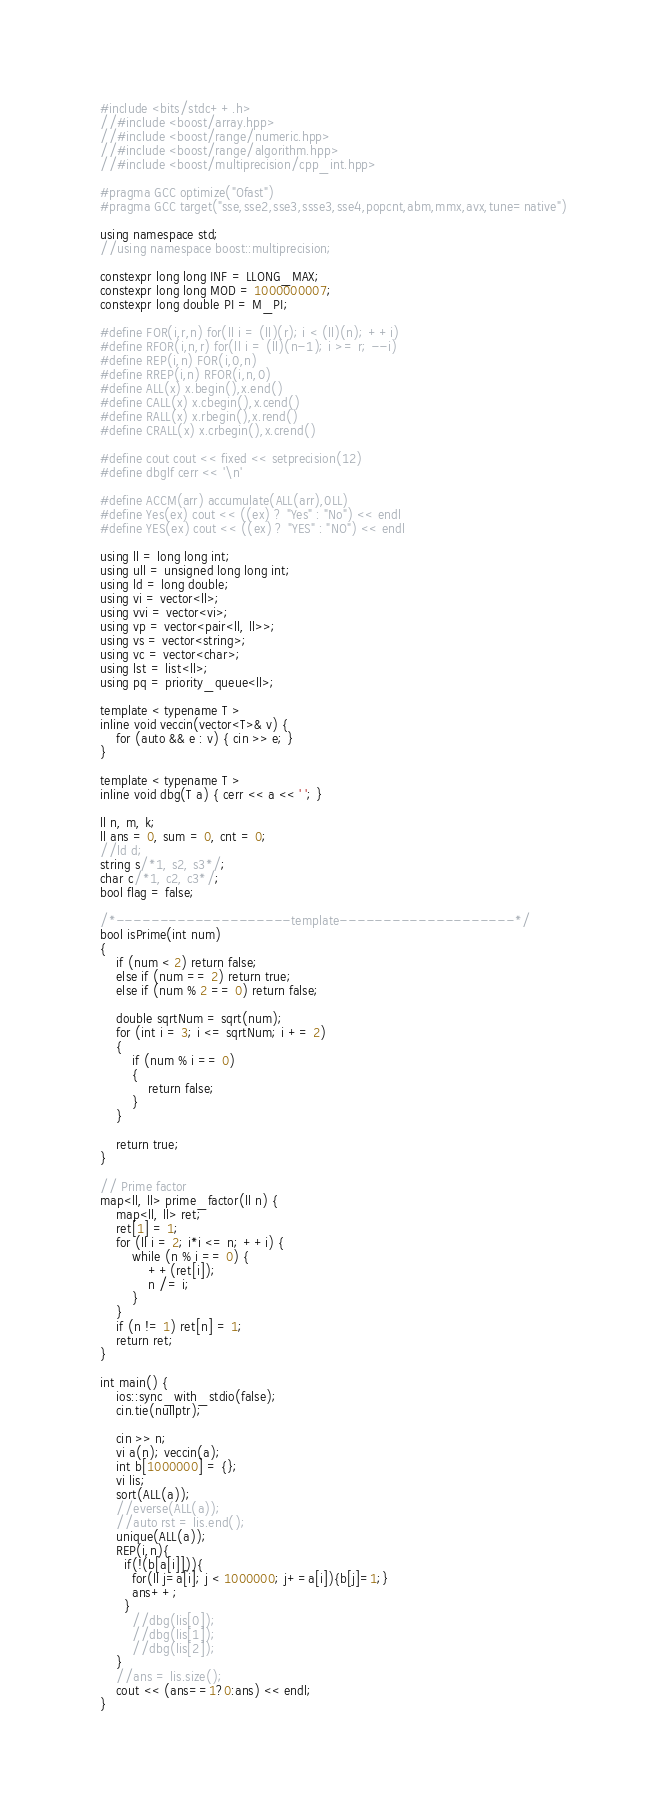Convert code to text. <code><loc_0><loc_0><loc_500><loc_500><_C++_>#include <bits/stdc++.h>
//#include <boost/array.hpp>
//#include <boost/range/numeric.hpp>
//#include <boost/range/algorithm.hpp>
//#include <boost/multiprecision/cpp_int.hpp>

#pragma GCC optimize("Ofast")
#pragma GCC target("sse,sse2,sse3,ssse3,sse4,popcnt,abm,mmx,avx,tune=native")

using namespace std;
//using namespace boost::multiprecision;

constexpr long long INF = LLONG_MAX;
constexpr long long MOD = 1000000007;
constexpr long double PI = M_PI;

#define FOR(i,r,n) for(ll i = (ll)(r); i < (ll)(n); ++i)
#define RFOR(i,n,r) for(ll i = (ll)(n-1); i >= r; --i)
#define REP(i,n) FOR(i,0,n)
#define RREP(i,n) RFOR(i,n,0)
#define ALL(x) x.begin(),x.end()
#define CALL(x) x.cbegin(),x.cend()
#define RALL(x) x.rbegin(),x.rend()
#define CRALL(x) x.crbegin(),x.crend()

#define cout cout << fixed << setprecision(12)
#define dbglf cerr << '\n'

#define ACCM(arr) accumulate(ALL(arr),0LL)
#define Yes(ex) cout << ((ex) ? "Yes" : "No") << endl
#define YES(ex) cout << ((ex) ? "YES" : "NO") << endl

using ll = long long int;
using ull = unsigned long long int;
using ld = long double;
using vi = vector<ll>;
using vvi = vector<vi>;
using vp = vector<pair<ll, ll>>;
using vs = vector<string>;
using vc = vector<char>;
using lst = list<ll>;
using pq = priority_queue<ll>;

template < typename T >
inline void veccin(vector<T>& v) {
    for (auto && e : v) { cin >> e; }
}

template < typename T >
inline void dbg(T a) { cerr << a << ' '; }

ll n, m, k;
ll ans = 0, sum = 0, cnt = 0;
//ld d;
string s/*1, s2, s3*/;
char c/*1, c2, c3*/;
bool flag = false;

/*--------------------template--------------------*/
bool isPrime(int num)
{
    if (num < 2) return false;
    else if (num == 2) return true;
    else if (num % 2 == 0) return false;

    double sqrtNum = sqrt(num);
    for (int i = 3; i <= sqrtNum; i += 2)
    {
        if (num % i == 0)
        {
            return false;
        }
    }

    return true;
}

// Prime factor
map<ll, ll> prime_factor(ll n) {
    map<ll, ll> ret;
    ret[1] = 1;
    for (ll i = 2; i*i <= n; ++i) {
        while (n % i == 0) {
            ++(ret[i]);
            n /= i;
        }
    }
    if (n != 1) ret[n] = 1;
    return ret;
}

int main() {
    ios::sync_with_stdio(false);
    cin.tie(nullptr);

    cin >> n;
    vi a(n); veccin(a);
	int b[1000000] = {};
  	vi lis;
	sort(ALL(a));
	//everse(ALL(a));
  	//auto rst = lis.end();
	unique(ALL(a));
    REP(i,n){
      if(!(b[a[i]])){
      	for(ll j=a[i]; j < 1000000; j+=a[i]){b[j]=1;}
        ans++;
      }
    	//dbg(lis[0]);
    	//dbg(lis[1]);
        //dbg(lis[2]);
    }
    //ans = lis.size();
    cout << (ans==1?0:ans) << endl;
}
</code> 